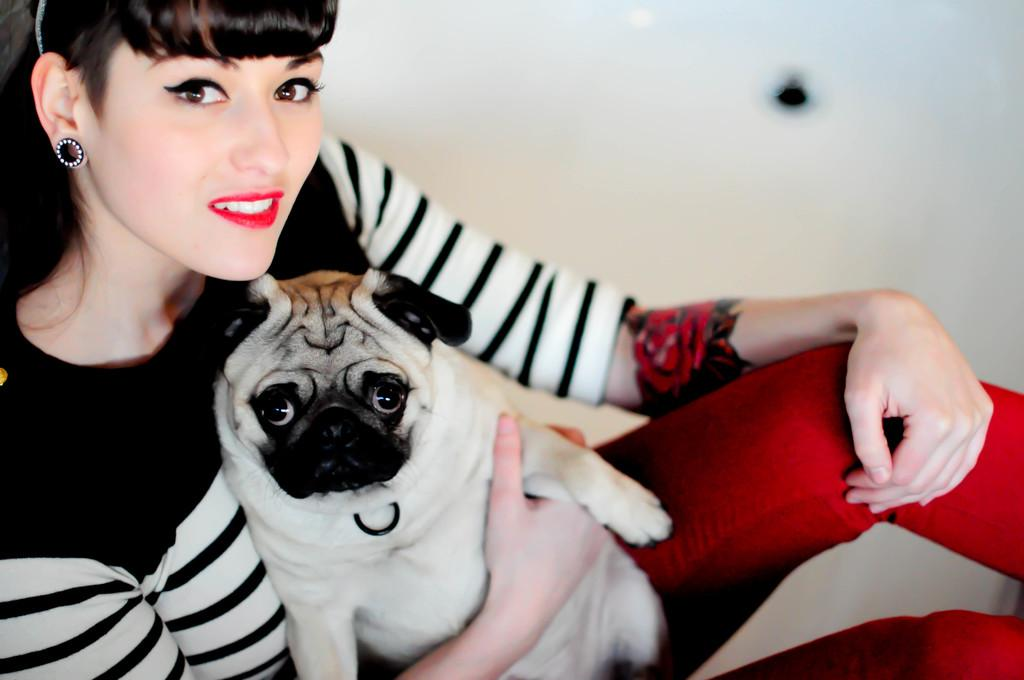Who is present in the image? There is a woman in the image. What is the woman holding? The woman is holding a dog. What expression does the woman have? The woman is smiling. What is the woman wearing? The woman is wearing a white and black T-shirt. What can be seen in the background of the image? There is a wall in the background of the image. What type of lettuce can be seen growing on the wall in the image? There is no lettuce present in the image, nor is there any indication of vegetation growing on the wall. 